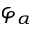Convert formula to latex. <formula><loc_0><loc_0><loc_500><loc_500>\varphi _ { \alpha }</formula> 